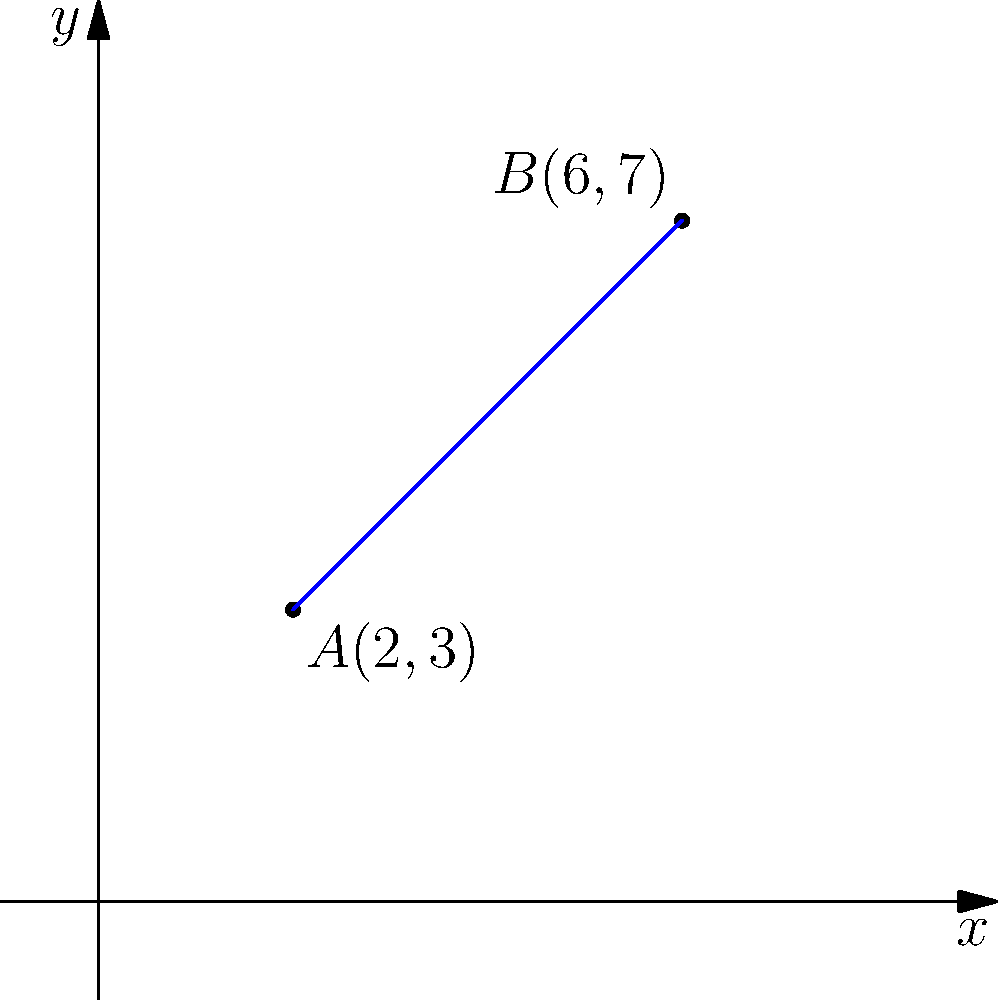In the graph above, points $A(2,3)$ and $B(6,7)$ are connected by a blue line. Calculate the slope of this line using the slope formula. Express your answer as a simplified fraction. To find the slope of a line passing through two points, we use the slope formula:

$$ m = \frac{y_2 - y_1}{x_2 - x_1} $$

Where $(x_1, y_1)$ is the first point and $(x_2, y_2)$ is the second point.

Step 1: Identify the coordinates of the two points:
Point $A: (x_1, y_1) = (2, 3)$
Point $B: (x_2, y_2) = (6, 7)$

Step 2: Substitute these values into the slope formula:

$$ m = \frac{7 - 3}{6 - 2} $$

Step 3: Simplify the numerator and denominator:

$$ m = \frac{4}{4} $$

Step 4: Simplify the fraction:

$$ m = 1 $$

Therefore, the slope of the line passing through points $A(2,3)$ and $B(6,7)$ is 1.
Answer: $1$ 